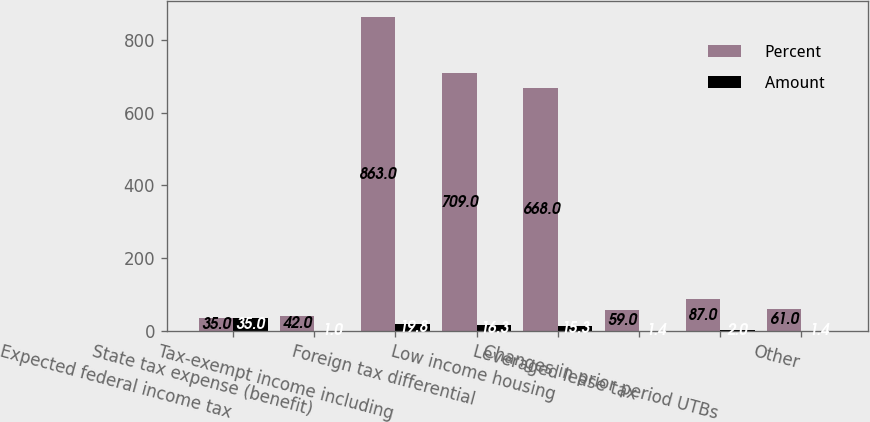<chart> <loc_0><loc_0><loc_500><loc_500><stacked_bar_chart><ecel><fcel>Expected federal income tax<fcel>State tax expense (benefit)<fcel>Tax-exempt income including<fcel>Foreign tax differential<fcel>Low income housing<fcel>Leveraged lease tax<fcel>Changes in prior period UTBs<fcel>Other<nl><fcel>Percent<fcel>35<fcel>42<fcel>863<fcel>709<fcel>668<fcel>59<fcel>87<fcel>61<nl><fcel>Amount<fcel>35<fcel>1<fcel>19.8<fcel>16.3<fcel>15.3<fcel>1.4<fcel>2<fcel>1.4<nl></chart> 